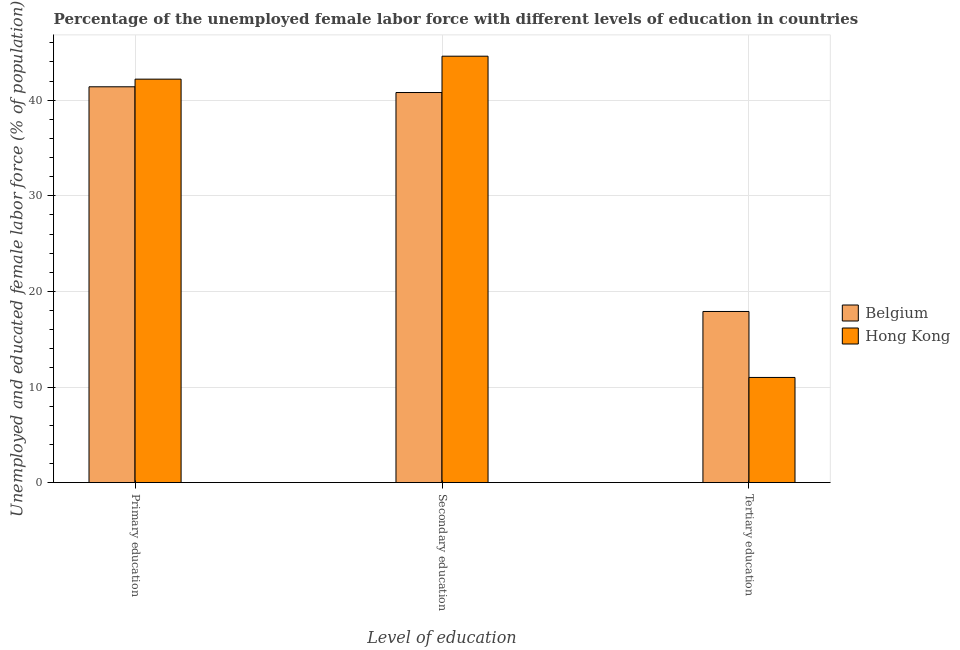How many different coloured bars are there?
Provide a short and direct response. 2. Are the number of bars per tick equal to the number of legend labels?
Offer a terse response. Yes. How many bars are there on the 3rd tick from the left?
Your response must be concise. 2. What is the label of the 3rd group of bars from the left?
Keep it short and to the point. Tertiary education. What is the percentage of female labor force who received secondary education in Hong Kong?
Your response must be concise. 44.6. Across all countries, what is the maximum percentage of female labor force who received secondary education?
Provide a succinct answer. 44.6. In which country was the percentage of female labor force who received secondary education maximum?
Your response must be concise. Hong Kong. In which country was the percentage of female labor force who received secondary education minimum?
Give a very brief answer. Belgium. What is the total percentage of female labor force who received primary education in the graph?
Your answer should be very brief. 83.6. What is the difference between the percentage of female labor force who received primary education in Hong Kong and that in Belgium?
Ensure brevity in your answer.  0.8. What is the difference between the percentage of female labor force who received tertiary education in Belgium and the percentage of female labor force who received secondary education in Hong Kong?
Your response must be concise. -26.7. What is the average percentage of female labor force who received tertiary education per country?
Offer a very short reply. 14.45. What is the difference between the percentage of female labor force who received primary education and percentage of female labor force who received secondary education in Belgium?
Give a very brief answer. 0.6. What is the ratio of the percentage of female labor force who received tertiary education in Hong Kong to that in Belgium?
Provide a succinct answer. 0.61. Is the difference between the percentage of female labor force who received secondary education in Hong Kong and Belgium greater than the difference between the percentage of female labor force who received tertiary education in Hong Kong and Belgium?
Give a very brief answer. Yes. What is the difference between the highest and the second highest percentage of female labor force who received tertiary education?
Ensure brevity in your answer.  6.9. What is the difference between the highest and the lowest percentage of female labor force who received secondary education?
Offer a very short reply. 3.8. Is the sum of the percentage of female labor force who received primary education in Hong Kong and Belgium greater than the maximum percentage of female labor force who received secondary education across all countries?
Give a very brief answer. Yes. What does the 2nd bar from the left in Primary education represents?
Your response must be concise. Hong Kong. What does the 1st bar from the right in Secondary education represents?
Offer a very short reply. Hong Kong. Is it the case that in every country, the sum of the percentage of female labor force who received primary education and percentage of female labor force who received secondary education is greater than the percentage of female labor force who received tertiary education?
Offer a very short reply. Yes. How many bars are there?
Your answer should be very brief. 6. Does the graph contain any zero values?
Ensure brevity in your answer.  No. How are the legend labels stacked?
Your response must be concise. Vertical. What is the title of the graph?
Your answer should be compact. Percentage of the unemployed female labor force with different levels of education in countries. What is the label or title of the X-axis?
Keep it short and to the point. Level of education. What is the label or title of the Y-axis?
Your answer should be compact. Unemployed and educated female labor force (% of population). What is the Unemployed and educated female labor force (% of population) of Belgium in Primary education?
Give a very brief answer. 41.4. What is the Unemployed and educated female labor force (% of population) in Hong Kong in Primary education?
Offer a very short reply. 42.2. What is the Unemployed and educated female labor force (% of population) in Belgium in Secondary education?
Keep it short and to the point. 40.8. What is the Unemployed and educated female labor force (% of population) of Hong Kong in Secondary education?
Your response must be concise. 44.6. What is the Unemployed and educated female labor force (% of population) in Belgium in Tertiary education?
Offer a terse response. 17.9. What is the Unemployed and educated female labor force (% of population) of Hong Kong in Tertiary education?
Your answer should be very brief. 11. Across all Level of education, what is the maximum Unemployed and educated female labor force (% of population) in Belgium?
Offer a very short reply. 41.4. Across all Level of education, what is the maximum Unemployed and educated female labor force (% of population) in Hong Kong?
Offer a very short reply. 44.6. Across all Level of education, what is the minimum Unemployed and educated female labor force (% of population) of Belgium?
Offer a very short reply. 17.9. What is the total Unemployed and educated female labor force (% of population) in Belgium in the graph?
Give a very brief answer. 100.1. What is the total Unemployed and educated female labor force (% of population) of Hong Kong in the graph?
Your response must be concise. 97.8. What is the difference between the Unemployed and educated female labor force (% of population) of Belgium in Primary education and that in Secondary education?
Your response must be concise. 0.6. What is the difference between the Unemployed and educated female labor force (% of population) in Hong Kong in Primary education and that in Tertiary education?
Make the answer very short. 31.2. What is the difference between the Unemployed and educated female labor force (% of population) of Belgium in Secondary education and that in Tertiary education?
Ensure brevity in your answer.  22.9. What is the difference between the Unemployed and educated female labor force (% of population) in Hong Kong in Secondary education and that in Tertiary education?
Your answer should be compact. 33.6. What is the difference between the Unemployed and educated female labor force (% of population) in Belgium in Primary education and the Unemployed and educated female labor force (% of population) in Hong Kong in Secondary education?
Your answer should be compact. -3.2. What is the difference between the Unemployed and educated female labor force (% of population) in Belgium in Primary education and the Unemployed and educated female labor force (% of population) in Hong Kong in Tertiary education?
Provide a succinct answer. 30.4. What is the difference between the Unemployed and educated female labor force (% of population) in Belgium in Secondary education and the Unemployed and educated female labor force (% of population) in Hong Kong in Tertiary education?
Ensure brevity in your answer.  29.8. What is the average Unemployed and educated female labor force (% of population) in Belgium per Level of education?
Keep it short and to the point. 33.37. What is the average Unemployed and educated female labor force (% of population) of Hong Kong per Level of education?
Offer a very short reply. 32.6. What is the difference between the Unemployed and educated female labor force (% of population) in Belgium and Unemployed and educated female labor force (% of population) in Hong Kong in Tertiary education?
Your answer should be compact. 6.9. What is the ratio of the Unemployed and educated female labor force (% of population) in Belgium in Primary education to that in Secondary education?
Provide a succinct answer. 1.01. What is the ratio of the Unemployed and educated female labor force (% of population) in Hong Kong in Primary education to that in Secondary education?
Provide a succinct answer. 0.95. What is the ratio of the Unemployed and educated female labor force (% of population) in Belgium in Primary education to that in Tertiary education?
Provide a short and direct response. 2.31. What is the ratio of the Unemployed and educated female labor force (% of population) of Hong Kong in Primary education to that in Tertiary education?
Offer a terse response. 3.84. What is the ratio of the Unemployed and educated female labor force (% of population) of Belgium in Secondary education to that in Tertiary education?
Ensure brevity in your answer.  2.28. What is the ratio of the Unemployed and educated female labor force (% of population) in Hong Kong in Secondary education to that in Tertiary education?
Offer a very short reply. 4.05. What is the difference between the highest and the second highest Unemployed and educated female labor force (% of population) in Hong Kong?
Make the answer very short. 2.4. What is the difference between the highest and the lowest Unemployed and educated female labor force (% of population) of Belgium?
Make the answer very short. 23.5. What is the difference between the highest and the lowest Unemployed and educated female labor force (% of population) in Hong Kong?
Ensure brevity in your answer.  33.6. 